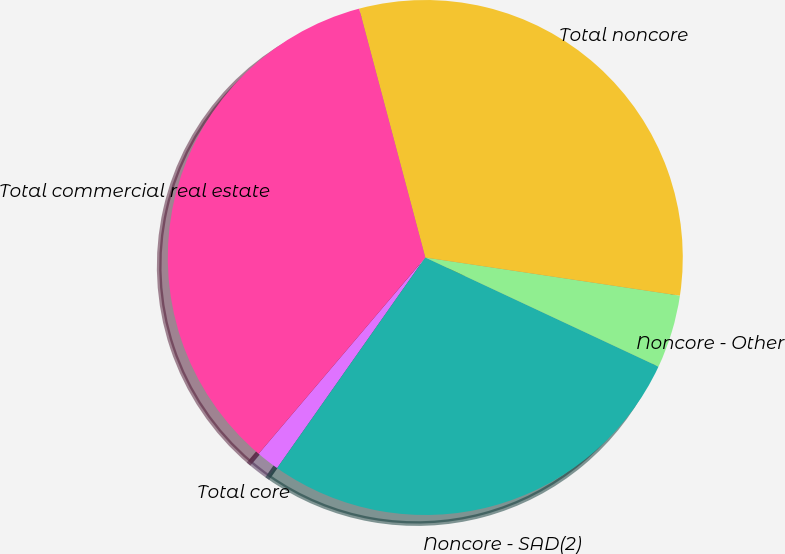<chart> <loc_0><loc_0><loc_500><loc_500><pie_chart><fcel>Total core<fcel>Noncore - SAD(2)<fcel>Noncore - Other<fcel>Total noncore<fcel>Total commercial real estate<nl><fcel>1.45%<fcel>27.79%<fcel>4.6%<fcel>31.5%<fcel>34.66%<nl></chart> 